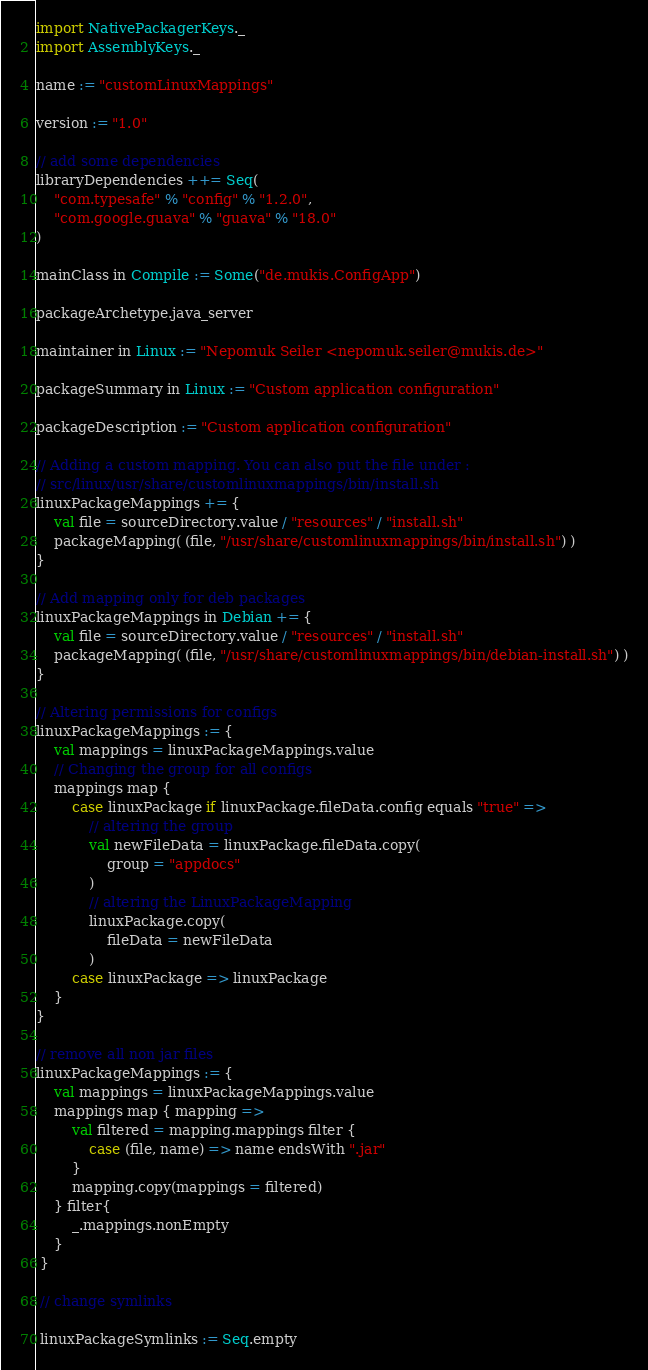Convert code to text. <code><loc_0><loc_0><loc_500><loc_500><_Scala_>import NativePackagerKeys._
import AssemblyKeys._

name := "customLinuxMappings"

version := "1.0"

// add some dependencies
libraryDependencies ++= Seq(
    "com.typesafe" % "config" % "1.2.0",
    "com.google.guava" % "guava" % "18.0"
)

mainClass in Compile := Some("de.mukis.ConfigApp")

packageArchetype.java_server

maintainer in Linux := "Nepomuk Seiler <nepomuk.seiler@mukis.de>"

packageSummary in Linux := "Custom application configuration"

packageDescription := "Custom application configuration"

// Adding a custom mapping. You can also put the file under :
// src/linux/usr/share/customlinuxmappings/bin/install.sh
linuxPackageMappings += {
    val file = sourceDirectory.value / "resources" / "install.sh"
    packageMapping( (file, "/usr/share/customlinuxmappings/bin/install.sh") )
}

// Add mapping only for deb packages
linuxPackageMappings in Debian += {
    val file = sourceDirectory.value / "resources" / "install.sh"
    packageMapping( (file, "/usr/share/customlinuxmappings/bin/debian-install.sh") )
}

// Altering permissions for configs
linuxPackageMappings := {
    val mappings = linuxPackageMappings.value
    // Changing the group for all configs
    mappings map { 
        case linuxPackage if linuxPackage.fileData.config equals "true" =>
            // altering the group
            val newFileData = linuxPackage.fileData.copy(
                group = "appdocs"
            )
            // altering the LinuxPackageMapping
            linuxPackage.copy(
                fileData = newFileData
            )
        case linuxPackage => linuxPackage
    }
}

// remove all non jar files
linuxPackageMappings := { 
    val mappings = linuxPackageMappings.value
    mappings map { mapping =>
        val filtered = mapping.mappings filter {
            case (file, name) => name endsWith ".jar"
        }
        mapping.copy(mappings = filtered)
    } filter{
        _.mappings.nonEmpty
    } 
 }
 
 // change symlinks
 
 linuxPackageSymlinks := Seq.empty
</code> 